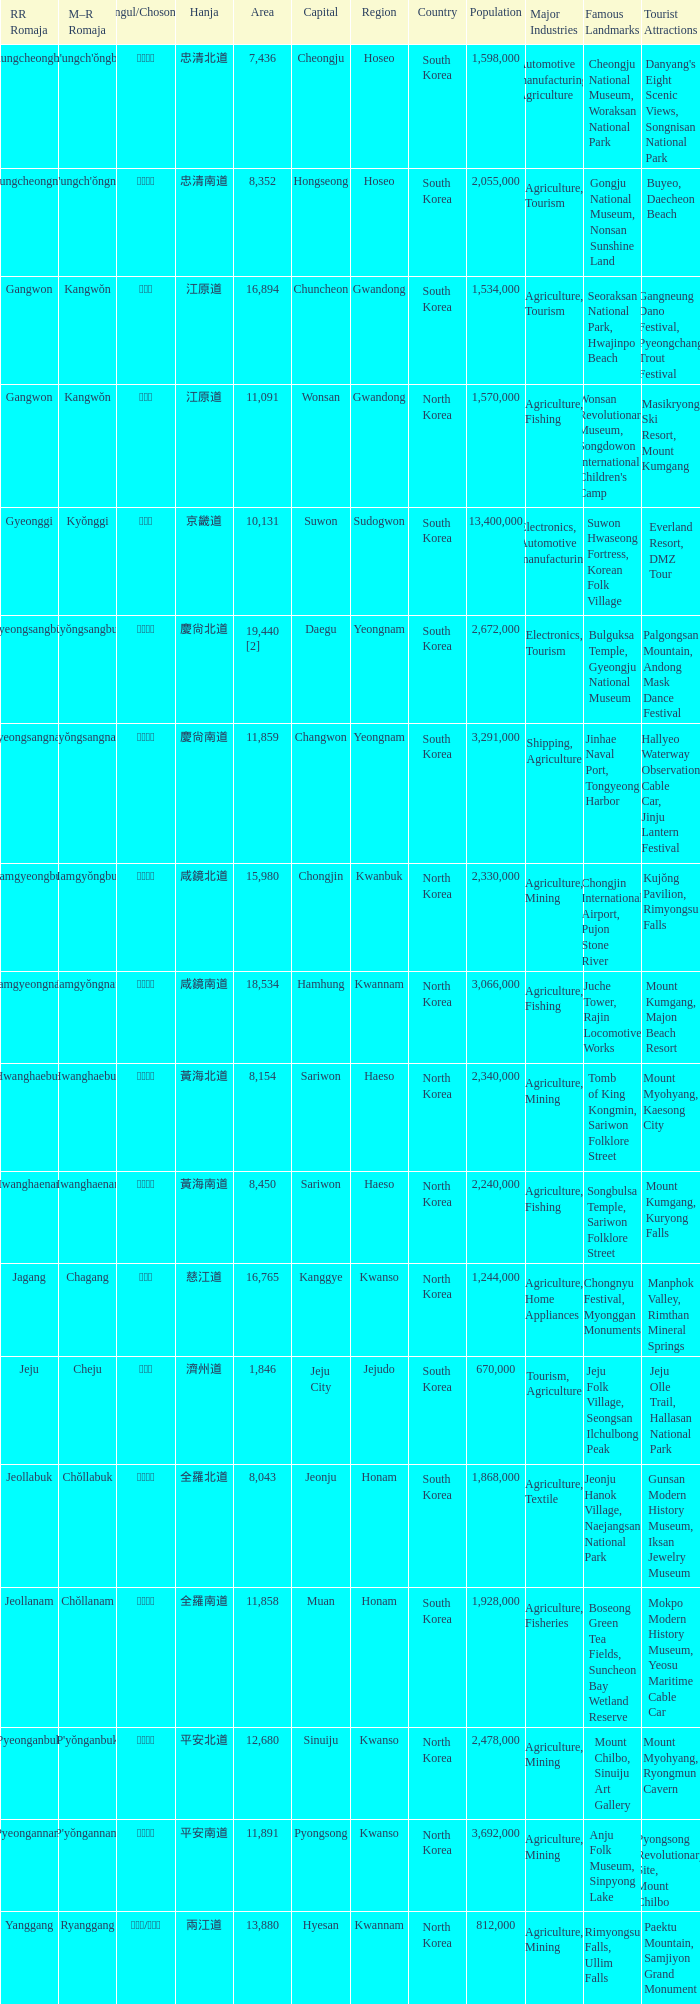What is the area for the province having Hangul of 경기도? 10131.0. 